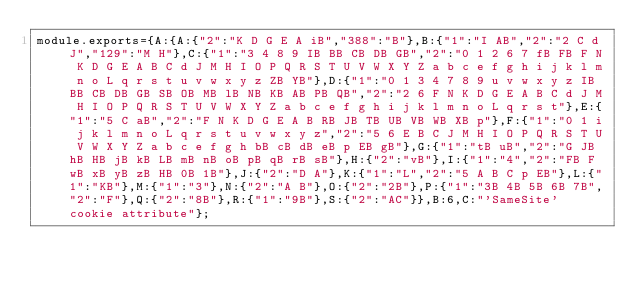<code> <loc_0><loc_0><loc_500><loc_500><_JavaScript_>module.exports={A:{A:{"2":"K D G E A iB","388":"B"},B:{"1":"I AB","2":"2 C d J","129":"M H"},C:{"1":"3 4 8 9 IB BB CB DB GB","2":"0 1 2 6 7 fB FB F N K D G E A B C d J M H I O P Q R S T U V W X Y Z a b c e f g h i j k l m n o L q r s t u v w x y z ZB YB"},D:{"1":"0 1 3 4 7 8 9 u v w x y z IB BB CB DB GB SB OB MB lB NB KB AB PB QB","2":"2 6 F N K D G E A B C d J M H I O P Q R S T U V W X Y Z a b c e f g h i j k l m n o L q r s t"},E:{"1":"5 C aB","2":"F N K D G E A B RB JB TB UB VB WB XB p"},F:{"1":"0 1 i j k l m n o L q r s t u v w x y z","2":"5 6 E B C J M H I O P Q R S T U V W X Y Z a b c e f g h bB cB dB eB p EB gB"},G:{"1":"tB uB","2":"G JB hB HB jB kB LB mB nB oB pB qB rB sB"},H:{"2":"vB"},I:{"1":"4","2":"FB F wB xB yB zB HB 0B 1B"},J:{"2":"D A"},K:{"1":"L","2":"5 A B C p EB"},L:{"1":"KB"},M:{"1":"3"},N:{"2":"A B"},O:{"2":"2B"},P:{"1":"3B 4B 5B 6B 7B","2":"F"},Q:{"2":"8B"},R:{"1":"9B"},S:{"2":"AC"}},B:6,C:"'SameSite' cookie attribute"};
</code> 